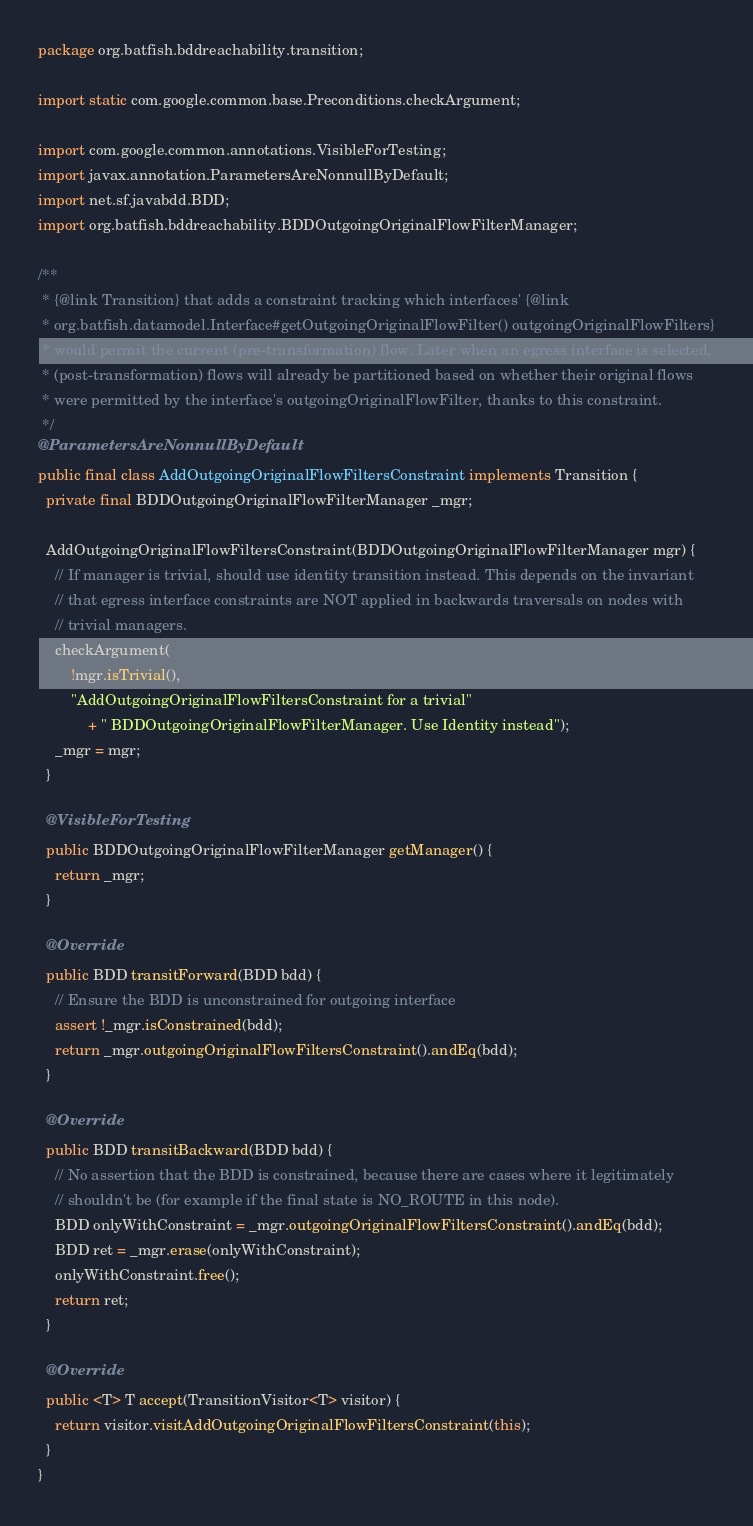Convert code to text. <code><loc_0><loc_0><loc_500><loc_500><_Java_>package org.batfish.bddreachability.transition;

import static com.google.common.base.Preconditions.checkArgument;

import com.google.common.annotations.VisibleForTesting;
import javax.annotation.ParametersAreNonnullByDefault;
import net.sf.javabdd.BDD;
import org.batfish.bddreachability.BDDOutgoingOriginalFlowFilterManager;

/**
 * {@link Transition} that adds a constraint tracking which interfaces' {@link
 * org.batfish.datamodel.Interface#getOutgoingOriginalFlowFilter() outgoingOriginalFlowFilters}
 * would permit the current (pre-transformation) flow. Later when an egress interface is selected,
 * (post-transformation) flows will already be partitioned based on whether their original flows
 * were permitted by the interface's outgoingOriginalFlowFilter, thanks to this constraint.
 */
@ParametersAreNonnullByDefault
public final class AddOutgoingOriginalFlowFiltersConstraint implements Transition {
  private final BDDOutgoingOriginalFlowFilterManager _mgr;

  AddOutgoingOriginalFlowFiltersConstraint(BDDOutgoingOriginalFlowFilterManager mgr) {
    // If manager is trivial, should use identity transition instead. This depends on the invariant
    // that egress interface constraints are NOT applied in backwards traversals on nodes with
    // trivial managers.
    checkArgument(
        !mgr.isTrivial(),
        "AddOutgoingOriginalFlowFiltersConstraint for a trivial"
            + " BDDOutgoingOriginalFlowFilterManager. Use Identity instead");
    _mgr = mgr;
  }

  @VisibleForTesting
  public BDDOutgoingOriginalFlowFilterManager getManager() {
    return _mgr;
  }

  @Override
  public BDD transitForward(BDD bdd) {
    // Ensure the BDD is unconstrained for outgoing interface
    assert !_mgr.isConstrained(bdd);
    return _mgr.outgoingOriginalFlowFiltersConstraint().andEq(bdd);
  }

  @Override
  public BDD transitBackward(BDD bdd) {
    // No assertion that the BDD is constrained, because there are cases where it legitimately
    // shouldn't be (for example if the final state is NO_ROUTE in this node).
    BDD onlyWithConstraint = _mgr.outgoingOriginalFlowFiltersConstraint().andEq(bdd);
    BDD ret = _mgr.erase(onlyWithConstraint);
    onlyWithConstraint.free();
    return ret;
  }

  @Override
  public <T> T accept(TransitionVisitor<T> visitor) {
    return visitor.visitAddOutgoingOriginalFlowFiltersConstraint(this);
  }
}
</code> 